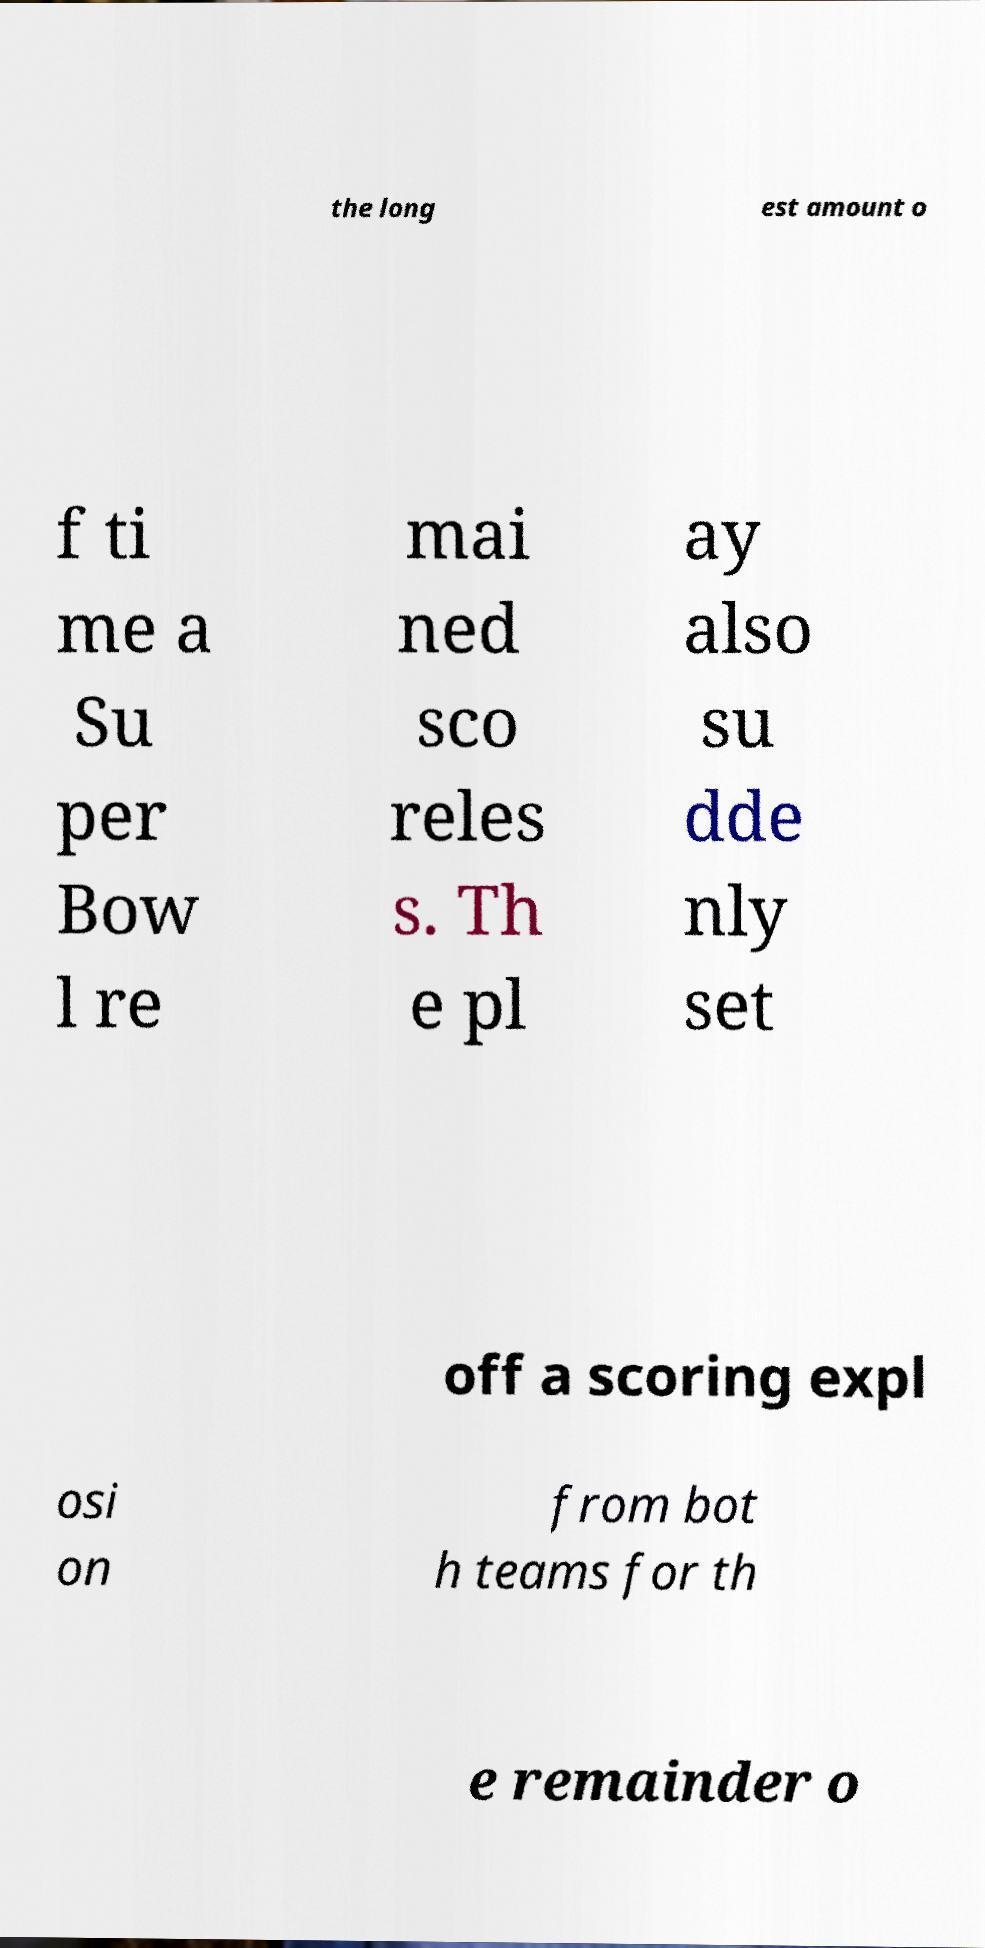Can you read and provide the text displayed in the image?This photo seems to have some interesting text. Can you extract and type it out for me? the long est amount o f ti me a Su per Bow l re mai ned sco reles s. Th e pl ay also su dde nly set off a scoring expl osi on from bot h teams for th e remainder o 